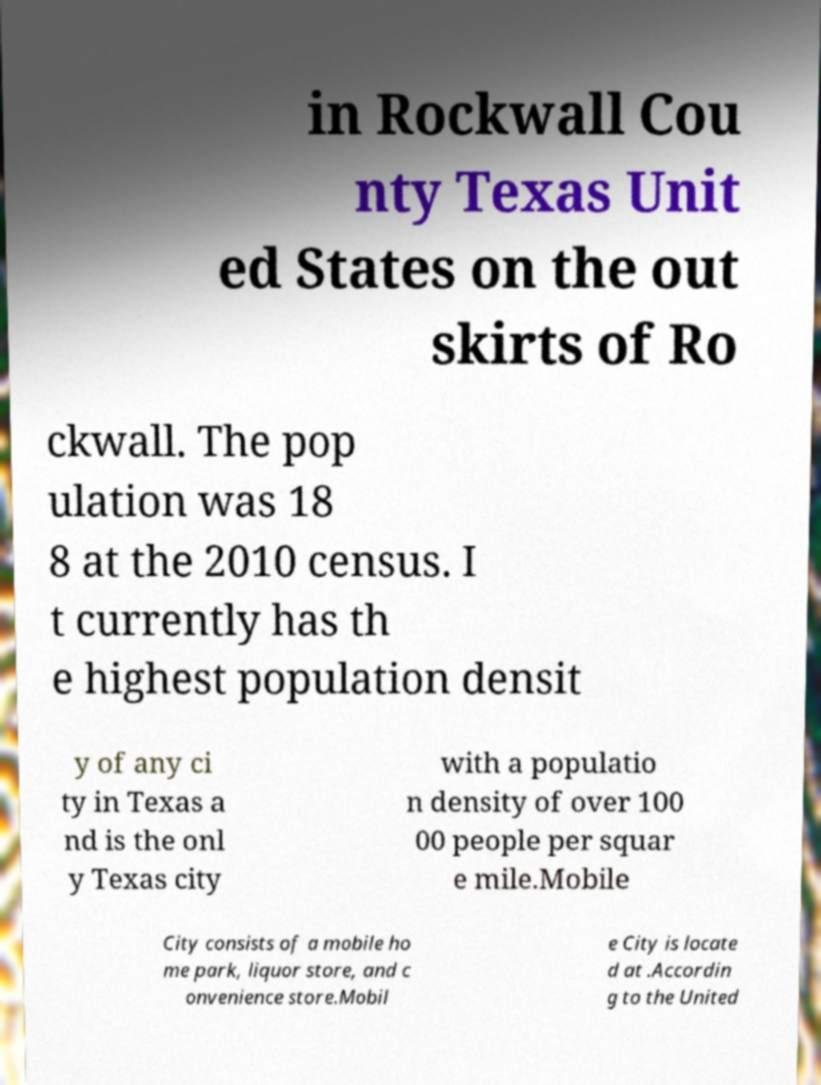Could you assist in decoding the text presented in this image and type it out clearly? in Rockwall Cou nty Texas Unit ed States on the out skirts of Ro ckwall. The pop ulation was 18 8 at the 2010 census. I t currently has th e highest population densit y of any ci ty in Texas a nd is the onl y Texas city with a populatio n density of over 100 00 people per squar e mile.Mobile City consists of a mobile ho me park, liquor store, and c onvenience store.Mobil e City is locate d at .Accordin g to the United 